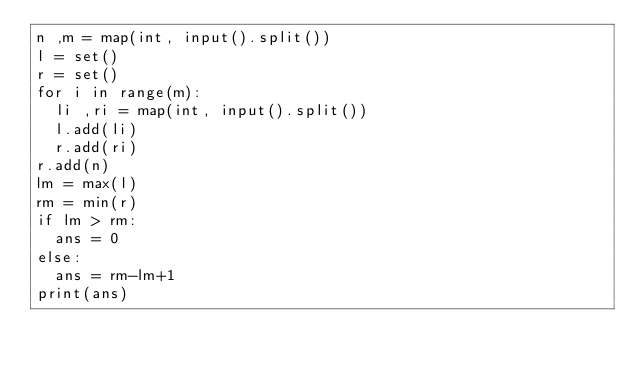Convert code to text. <code><loc_0><loc_0><loc_500><loc_500><_Python_>n ,m = map(int, input().split())
l = set()
r = set()
for i in range(m):
  li ,ri = map(int, input().split())
  l.add(li)
  r.add(ri)
r.add(n)
lm = max(l)
rm = min(r)
if lm > rm:
  ans = 0
else:
  ans = rm-lm+1
print(ans)</code> 